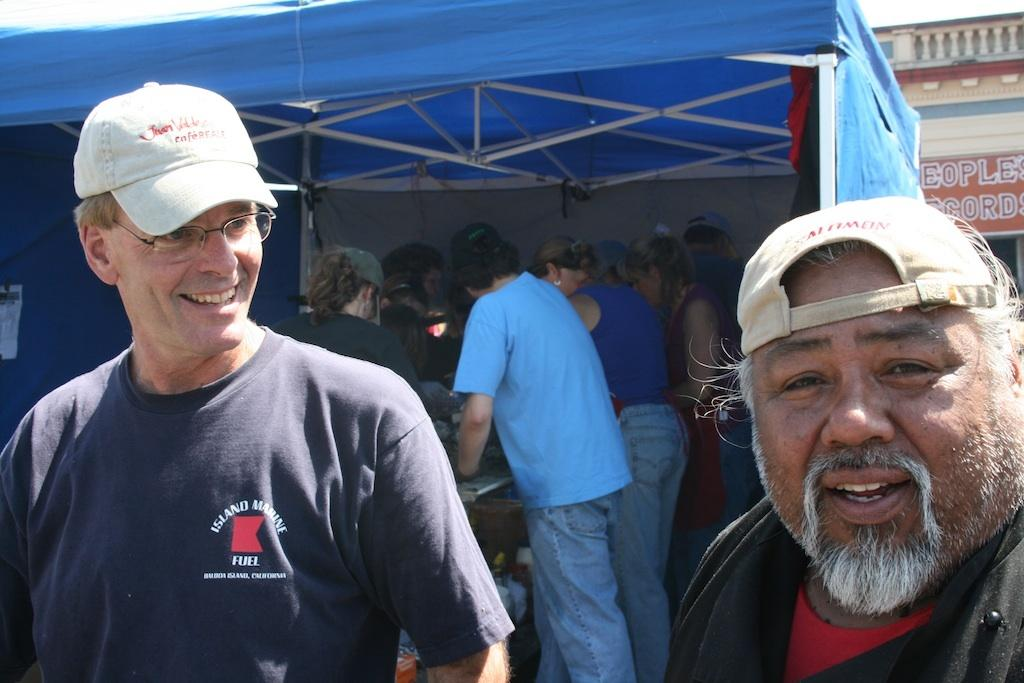What are the two people in the image wearing on their heads? Two people are wearing hats in the image. How is one of the men in the image expressing himself? One man is smiling and looking at the other person. What can be seen in the background of the image? There are people, a tent, a building, and a hoarding in the background of the image. What direction is the hammer being swung in the image? There is no hammer present in the image. What type of lipstick is the person wearing in the image? There is no lipstick or person wearing lipstick in the image. 